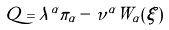<formula> <loc_0><loc_0><loc_500><loc_500>Q = \lambda ^ { \alpha } \pi _ { \alpha } - \nu ^ { \alpha } W _ { \alpha } ( \xi )</formula> 